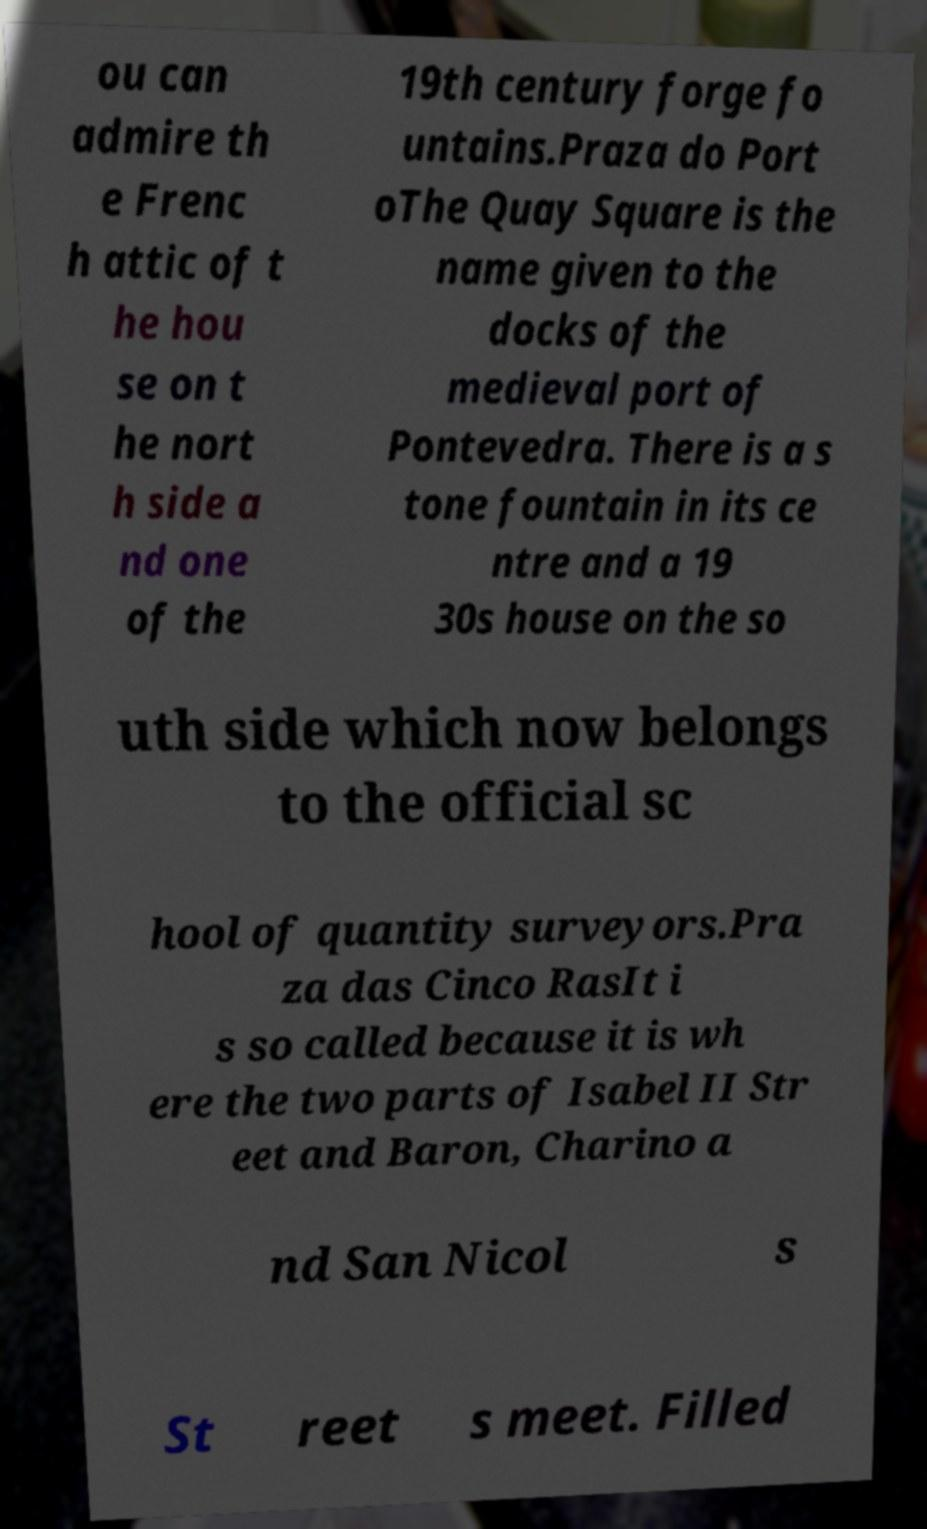For documentation purposes, I need the text within this image transcribed. Could you provide that? ou can admire th e Frenc h attic of t he hou se on t he nort h side a nd one of the 19th century forge fo untains.Praza do Port oThe Quay Square is the name given to the docks of the medieval port of Pontevedra. There is a s tone fountain in its ce ntre and a 19 30s house on the so uth side which now belongs to the official sc hool of quantity surveyors.Pra za das Cinco RasIt i s so called because it is wh ere the two parts of Isabel II Str eet and Baron, Charino a nd San Nicol s St reet s meet. Filled 